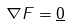Convert formula to latex. <formula><loc_0><loc_0><loc_500><loc_500>\nabla F = \underline { 0 }</formula> 